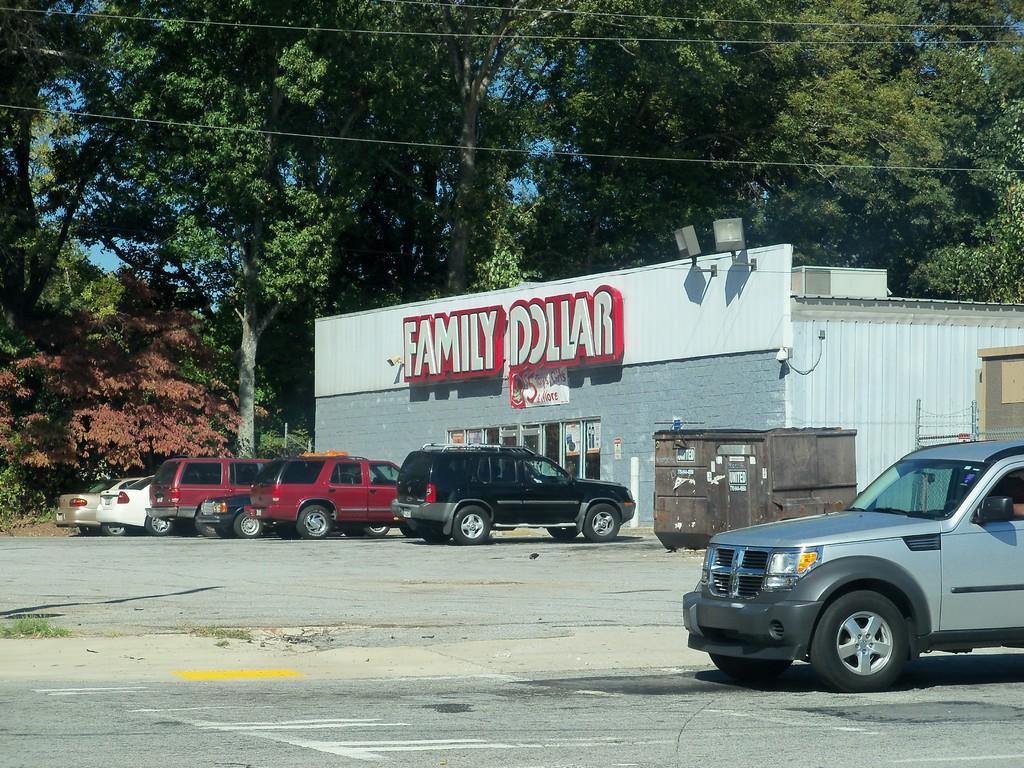How would you summarize this image in a sentence or two? In this picture I can observe some cars parked in the parking lot in the middle of the picture. In front of the cars I can observe a building. In the background there are trees. 